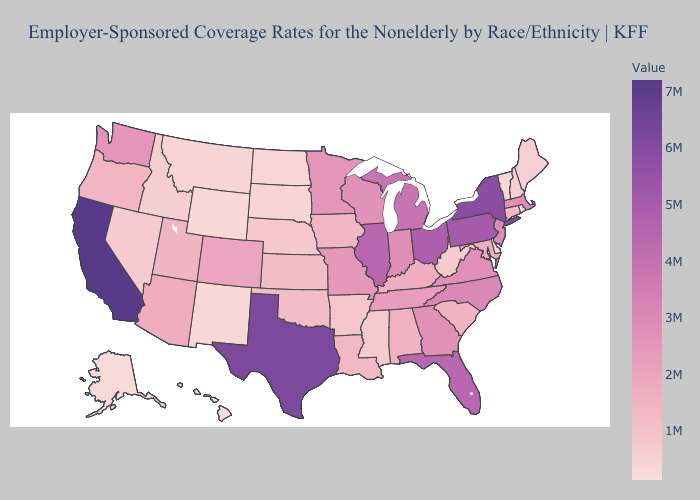Does Maine have the highest value in the USA?
Short answer required. No. Which states hav the highest value in the MidWest?
Keep it brief. Ohio. Among the states that border Connecticut , does Rhode Island have the lowest value?
Write a very short answer. Yes. Does Oklahoma have the lowest value in the South?
Give a very brief answer. No. Does New York have the highest value in the Northeast?
Give a very brief answer. Yes. Among the states that border California , does Oregon have the highest value?
Quick response, please. No. 